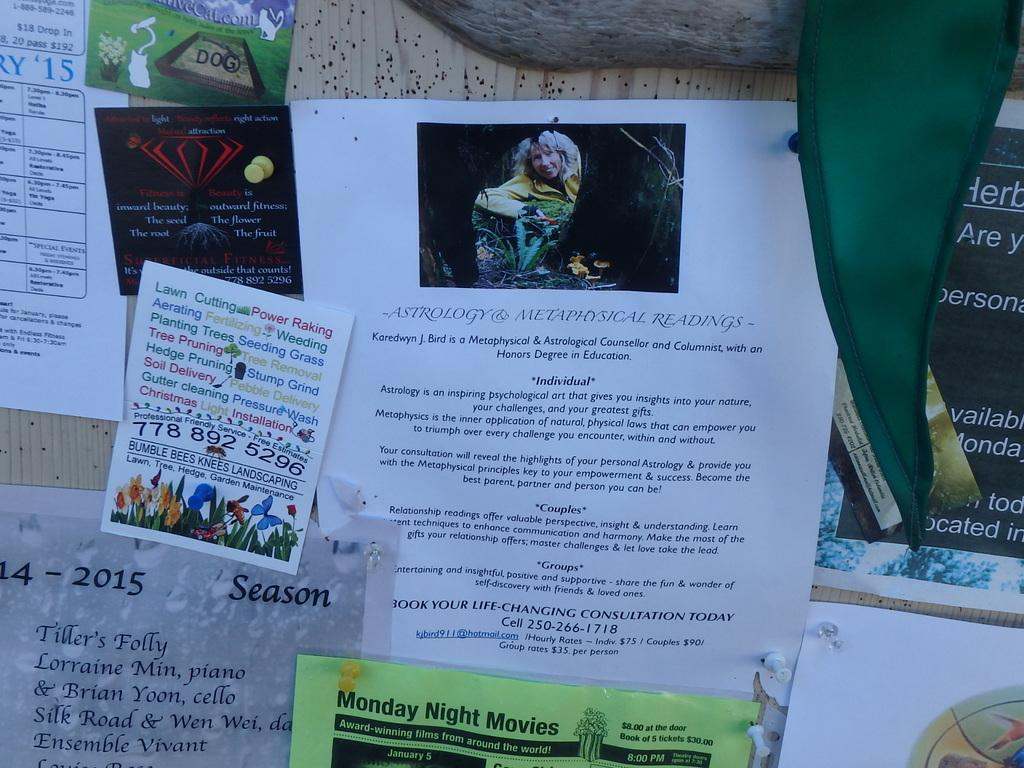<image>
Offer a succinct explanation of the picture presented. some papers with one that has the year 2015 on it 